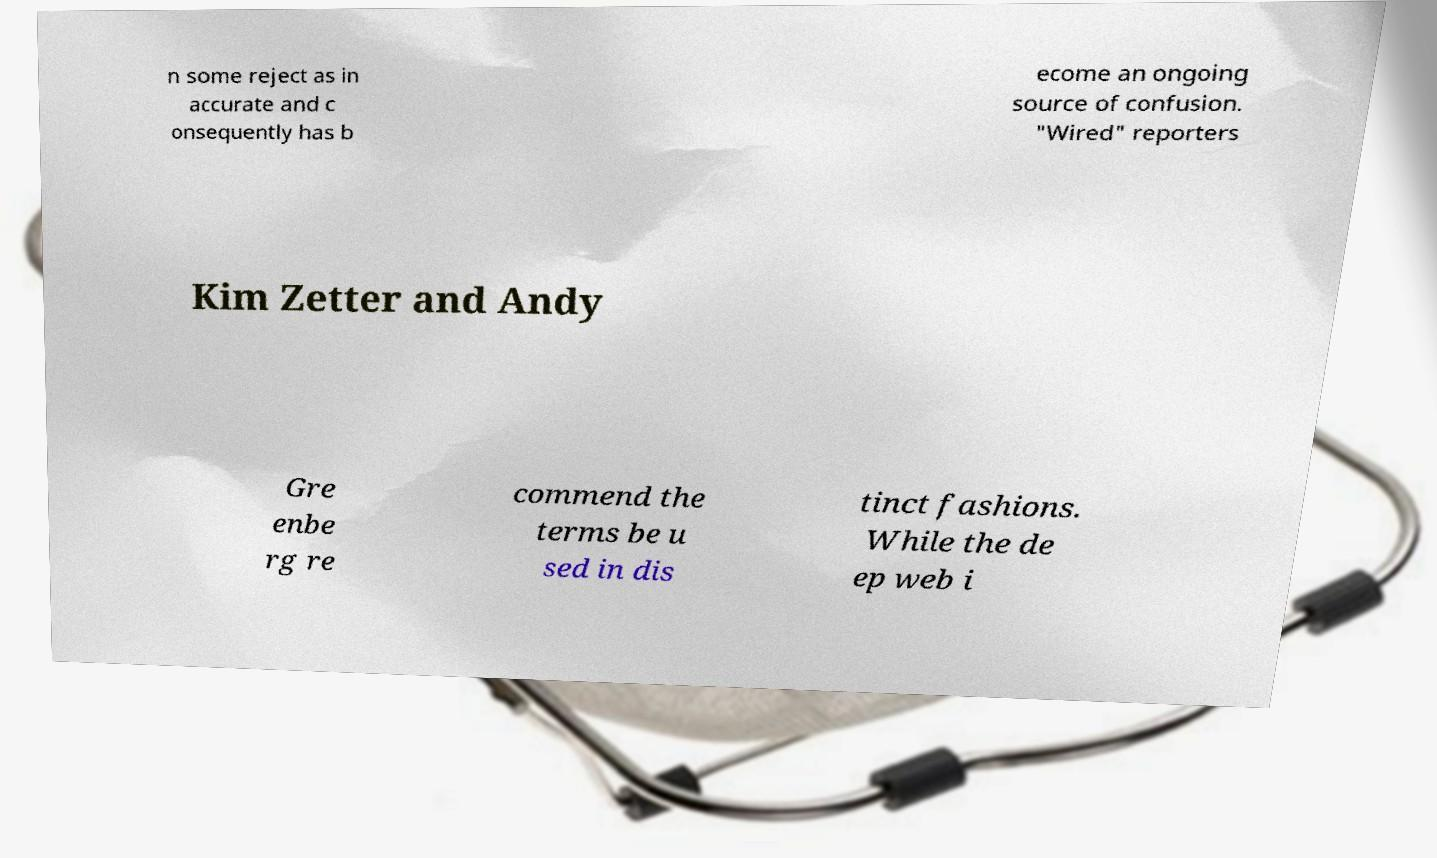Please identify and transcribe the text found in this image. n some reject as in accurate and c onsequently has b ecome an ongoing source of confusion. "Wired" reporters Kim Zetter and Andy Gre enbe rg re commend the terms be u sed in dis tinct fashions. While the de ep web i 